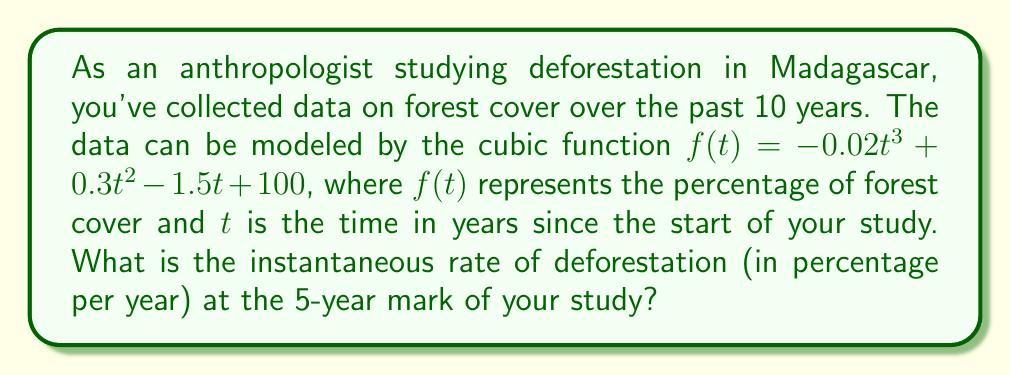Show me your answer to this math problem. To find the instantaneous rate of deforestation at $t = 5$ years, we need to calculate the derivative of the given function $f(t)$ and evaluate it at $t = 5$. The derivative will give us the rate of change of forest cover with respect to time.

1) Given function: $f(t) = -0.02t^3 + 0.3t^2 - 1.5t + 100$

2) To find the derivative, we apply the power rule:
   $f'(t) = (-0.02 \cdot 3)t^2 + (0.3 \cdot 2)t - 1.5$
   $f'(t) = -0.06t^2 + 0.6t - 1.5$

3) Now, we evaluate $f'(t)$ at $t = 5$:
   $f'(5) = -0.06(5)^2 + 0.6(5) - 1.5$
   $f'(5) = -0.06(25) + 3 - 1.5$
   $f'(5) = -1.5 + 3 - 1.5$
   $f'(5) = 0$

4) The negative of this value gives us the rate of deforestation:
   Rate of deforestation = $-f'(5) = -(0) = 0$

Therefore, the instantaneous rate of deforestation at the 5-year mark is 0 percentage per year.
Answer: 0 percentage per year 